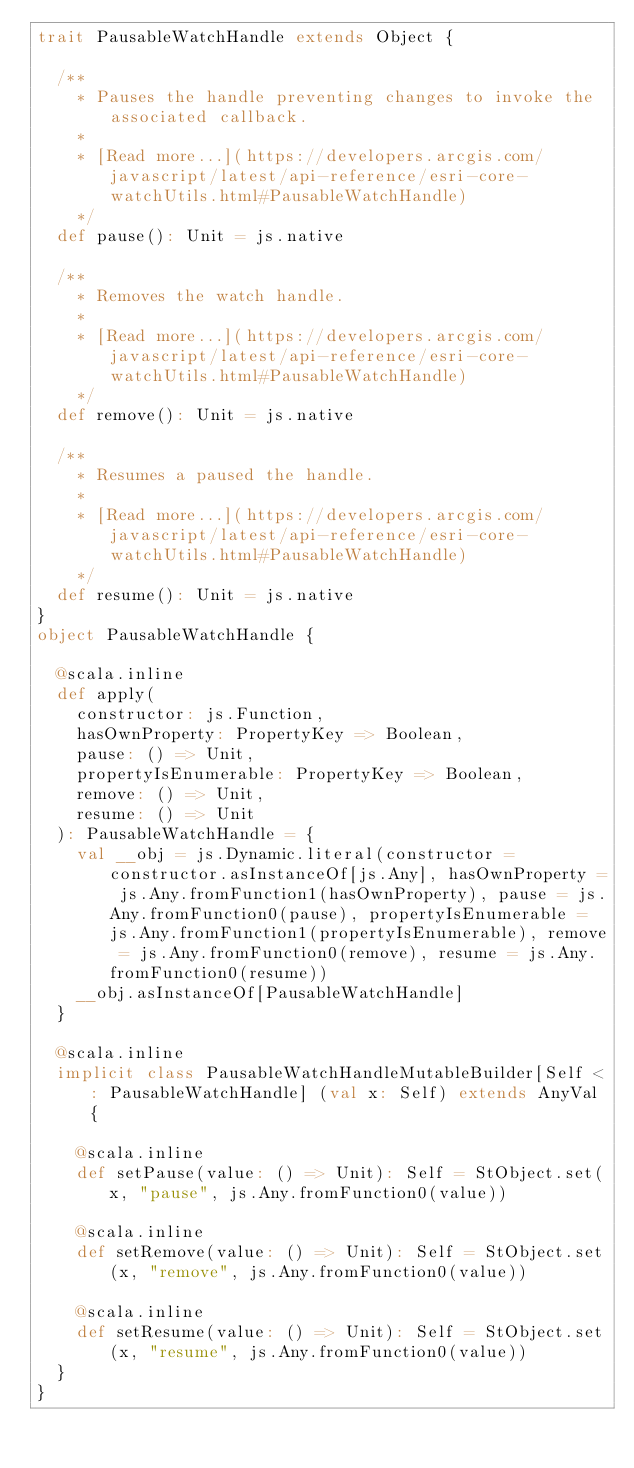Convert code to text. <code><loc_0><loc_0><loc_500><loc_500><_Scala_>trait PausableWatchHandle extends Object {
  
  /**
    * Pauses the handle preventing changes to invoke the associated callback.
    *
    * [Read more...](https://developers.arcgis.com/javascript/latest/api-reference/esri-core-watchUtils.html#PausableWatchHandle)
    */
  def pause(): Unit = js.native
  
  /**
    * Removes the watch handle.
    *
    * [Read more...](https://developers.arcgis.com/javascript/latest/api-reference/esri-core-watchUtils.html#PausableWatchHandle)
    */
  def remove(): Unit = js.native
  
  /**
    * Resumes a paused the handle.
    *
    * [Read more...](https://developers.arcgis.com/javascript/latest/api-reference/esri-core-watchUtils.html#PausableWatchHandle)
    */
  def resume(): Unit = js.native
}
object PausableWatchHandle {
  
  @scala.inline
  def apply(
    constructor: js.Function,
    hasOwnProperty: PropertyKey => Boolean,
    pause: () => Unit,
    propertyIsEnumerable: PropertyKey => Boolean,
    remove: () => Unit,
    resume: () => Unit
  ): PausableWatchHandle = {
    val __obj = js.Dynamic.literal(constructor = constructor.asInstanceOf[js.Any], hasOwnProperty = js.Any.fromFunction1(hasOwnProperty), pause = js.Any.fromFunction0(pause), propertyIsEnumerable = js.Any.fromFunction1(propertyIsEnumerable), remove = js.Any.fromFunction0(remove), resume = js.Any.fromFunction0(resume))
    __obj.asInstanceOf[PausableWatchHandle]
  }
  
  @scala.inline
  implicit class PausableWatchHandleMutableBuilder[Self <: PausableWatchHandle] (val x: Self) extends AnyVal {
    
    @scala.inline
    def setPause(value: () => Unit): Self = StObject.set(x, "pause", js.Any.fromFunction0(value))
    
    @scala.inline
    def setRemove(value: () => Unit): Self = StObject.set(x, "remove", js.Any.fromFunction0(value))
    
    @scala.inline
    def setResume(value: () => Unit): Self = StObject.set(x, "resume", js.Any.fromFunction0(value))
  }
}
</code> 